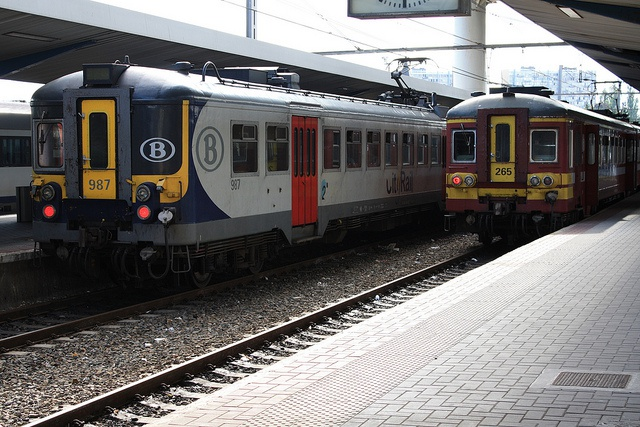Describe the objects in this image and their specific colors. I can see train in lightgray, black, gray, white, and maroon tones, train in lightgray, black, olive, gray, and maroon tones, train in lightgray, black, and gray tones, and clock in lightgray, darkgray, gray, and black tones in this image. 